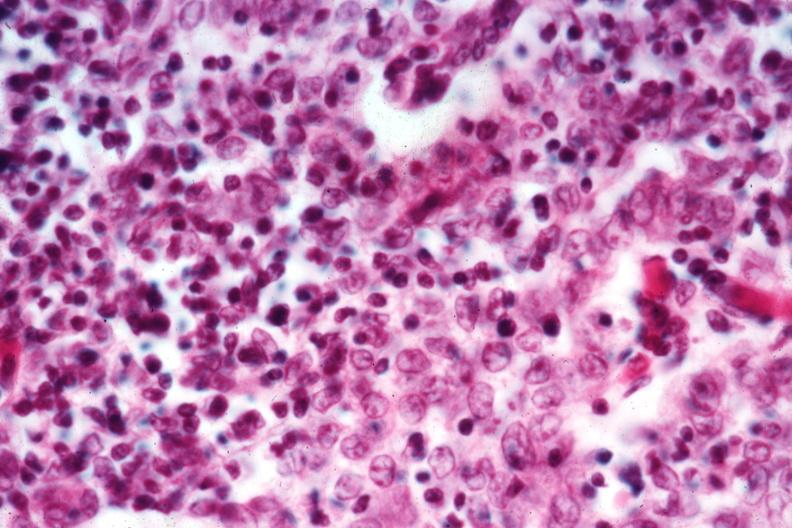s thymus present?
Answer the question using a single word or phrase. Yes 